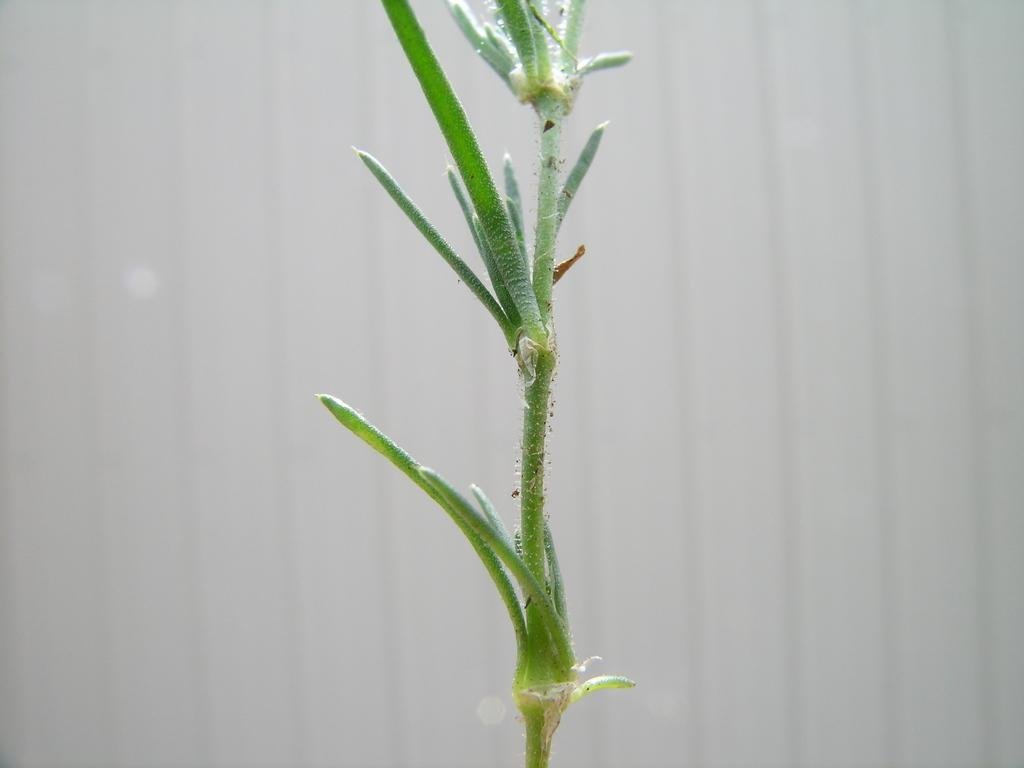What type of living organism can be seen in the image? There is a plant in the image. What advice does the plant give to its mom in the image? There is no mom or advice present in the image, as it only features a plant. 